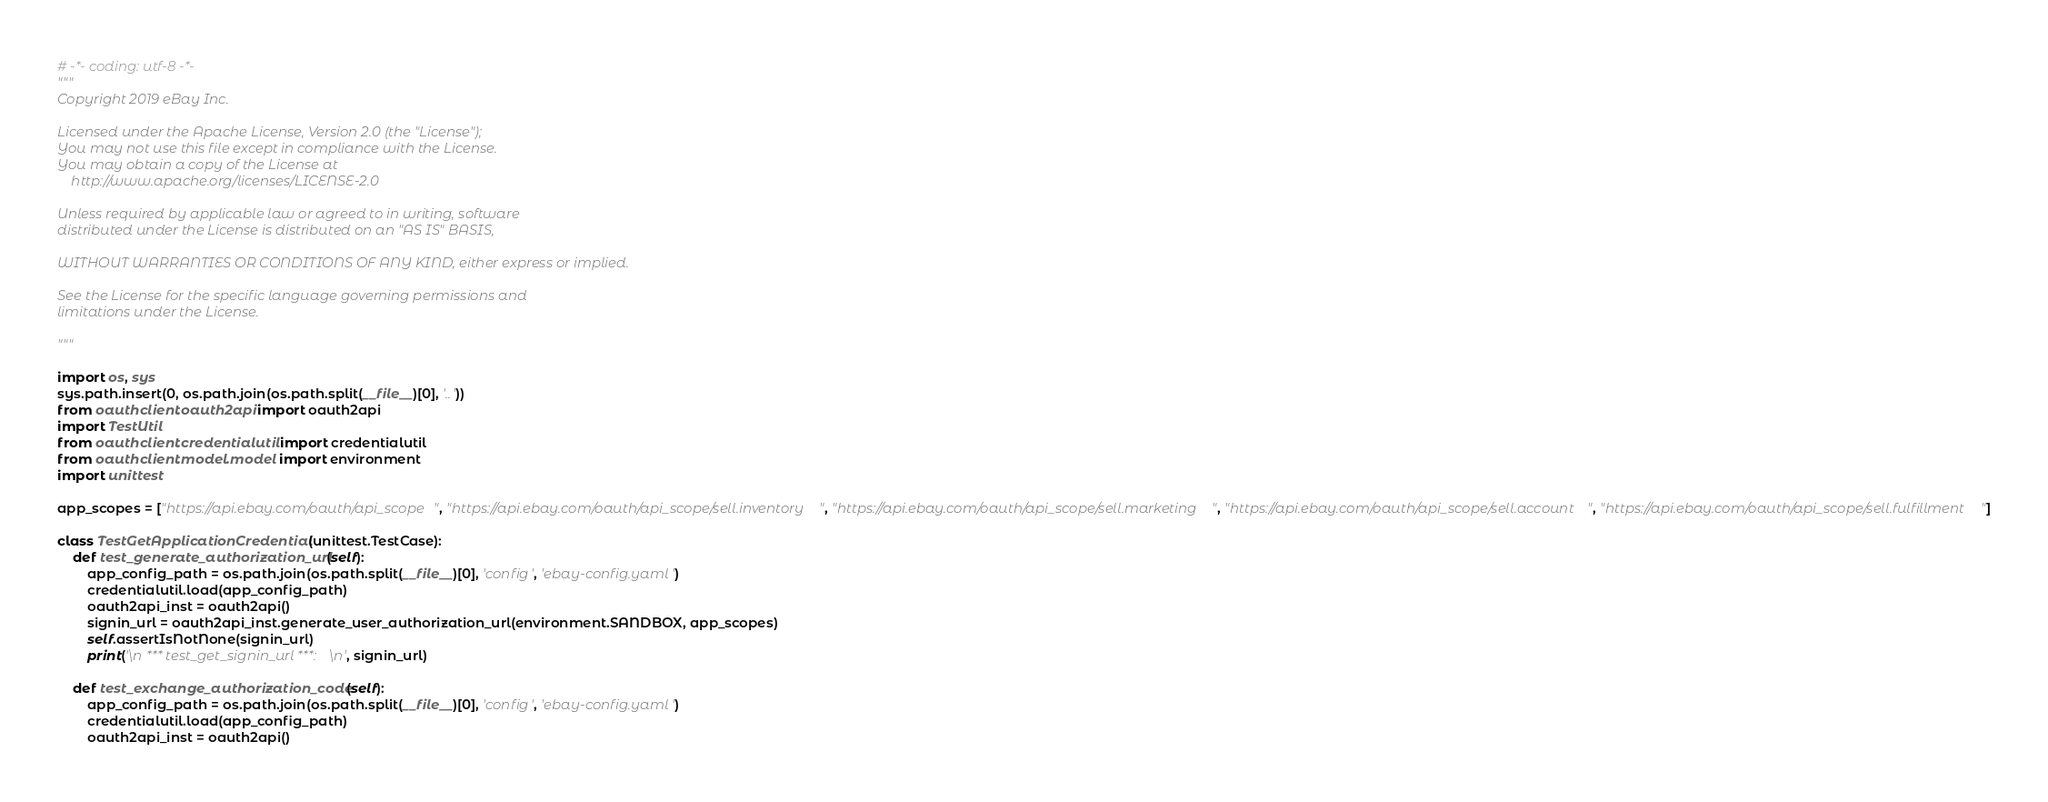Convert code to text. <code><loc_0><loc_0><loc_500><loc_500><_Python_># -*- coding: utf-8 -*-
"""
Copyright 2019 eBay Inc.
 
Licensed under the Apache License, Version 2.0 (the "License");
You may not use this file except in compliance with the License.
You may obtain a copy of the License at
    http://www.apache.org/licenses/LICENSE-2.0

Unless required by applicable law or agreed to in writing, software
distributed under the License is distributed on an "AS IS" BASIS,

WITHOUT WARRANTIES OR CONDITIONS OF ANY KIND, either express or implied.

See the License for the specific language governing permissions and
limitations under the License.

"""

import os, sys
sys.path.insert(0, os.path.join(os.path.split(__file__)[0], '..'))
from oauthclient.oauth2api import oauth2api
import TestUtil
from oauthclient.credentialutil import credentialutil
from oauthclient.model.model import environment
import unittest

app_scopes = ["https://api.ebay.com/oauth/api_scope", "https://api.ebay.com/oauth/api_scope/sell.inventory", "https://api.ebay.com/oauth/api_scope/sell.marketing", "https://api.ebay.com/oauth/api_scope/sell.account", "https://api.ebay.com/oauth/api_scope/sell.fulfillment"]

class TestGetApplicationCredential(unittest.TestCase):
    def test_generate_authorization_url(self):
        app_config_path = os.path.join(os.path.split(__file__)[0], 'config', 'ebay-config.yaml')
        credentialutil.load(app_config_path)
        oauth2api_inst = oauth2api()
        signin_url = oauth2api_inst.generate_user_authorization_url(environment.SANDBOX, app_scopes)
        self.assertIsNotNone(signin_url)
        print('\n *** test_get_signin_url ***: \n', signin_url)
    
    def test_exchange_authorization_code(self):
        app_config_path = os.path.join(os.path.split(__file__)[0], 'config', 'ebay-config.yaml')
        credentialutil.load(app_config_path)
        oauth2api_inst = oauth2api()</code> 